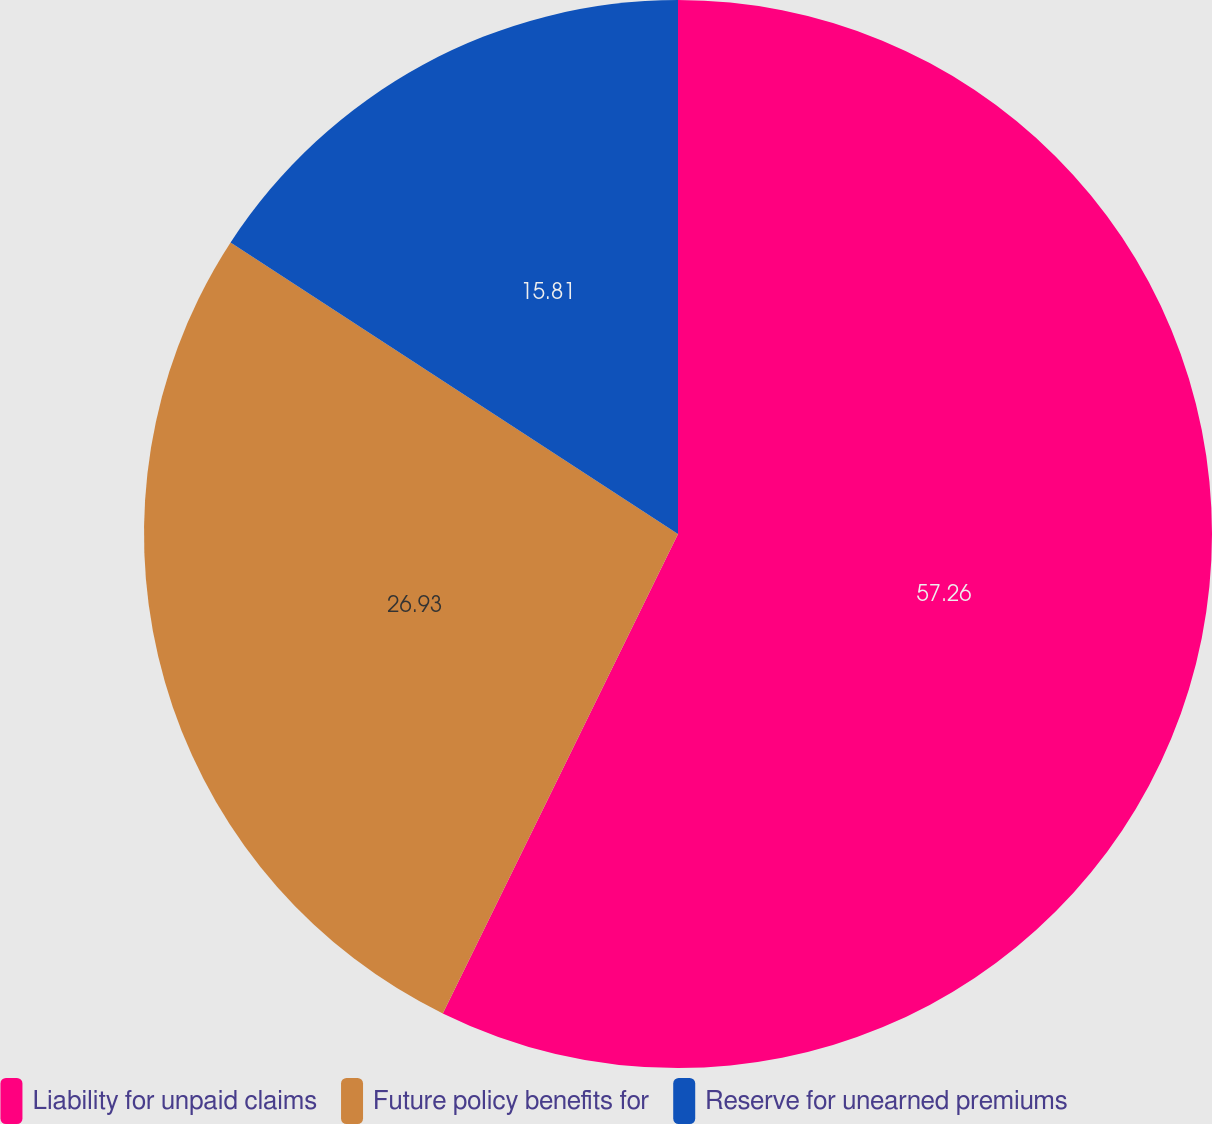Convert chart to OTSL. <chart><loc_0><loc_0><loc_500><loc_500><pie_chart><fcel>Liability for unpaid claims<fcel>Future policy benefits for<fcel>Reserve for unearned premiums<nl><fcel>57.26%<fcel>26.93%<fcel>15.81%<nl></chart> 